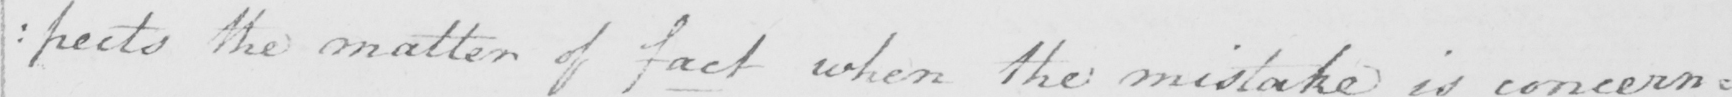Can you read and transcribe this handwriting? : pects the matter of fact when the mistake is concerning 